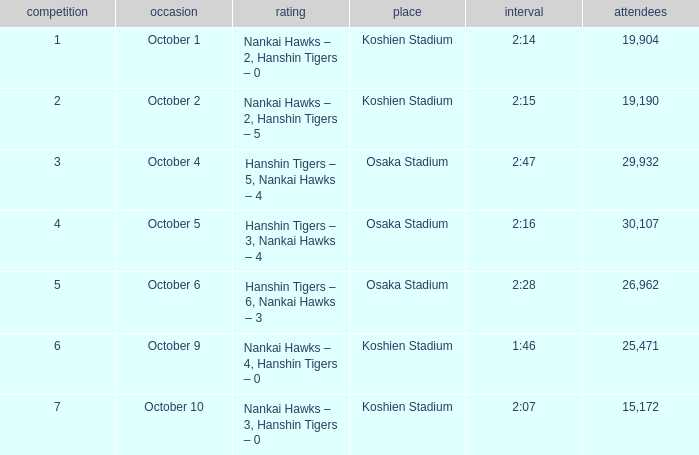How many games have an Attendance of 19,190? 1.0. 